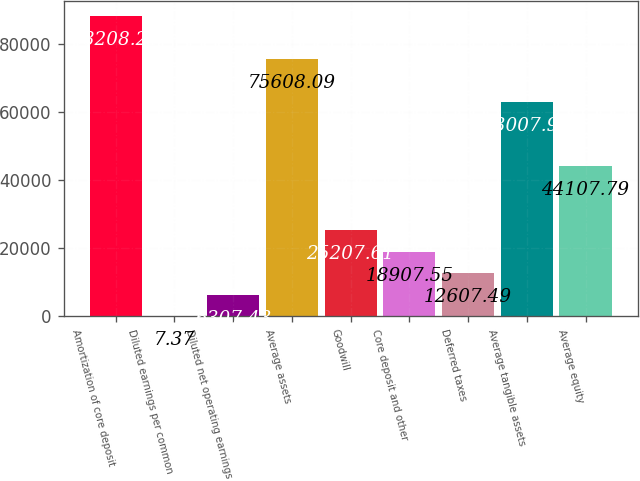Convert chart. <chart><loc_0><loc_0><loc_500><loc_500><bar_chart><fcel>Amortization of core deposit<fcel>Diluted earnings per common<fcel>Diluted net operating earnings<fcel>Average assets<fcel>Goodwill<fcel>Core deposit and other<fcel>Deferred taxes<fcel>Average tangible assets<fcel>Average equity<nl><fcel>88208.2<fcel>7.37<fcel>6307.43<fcel>75608.1<fcel>25207.6<fcel>18907.5<fcel>12607.5<fcel>63008<fcel>44107.8<nl></chart> 